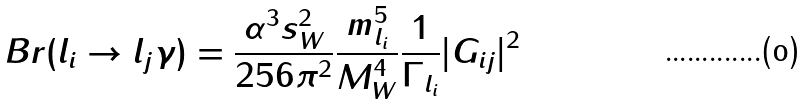<formula> <loc_0><loc_0><loc_500><loc_500>B r ( l _ { i } \to l _ { j } \gamma ) = \frac { \alpha ^ { 3 } s _ { W } ^ { 2 } } { 2 5 6 \pi ^ { 2 } } \frac { m _ { l _ { i } } ^ { 5 } } { M _ { W } ^ { 4 } } \frac { 1 } { \Gamma _ { l _ { i } } } | G _ { i j } | ^ { 2 }</formula> 